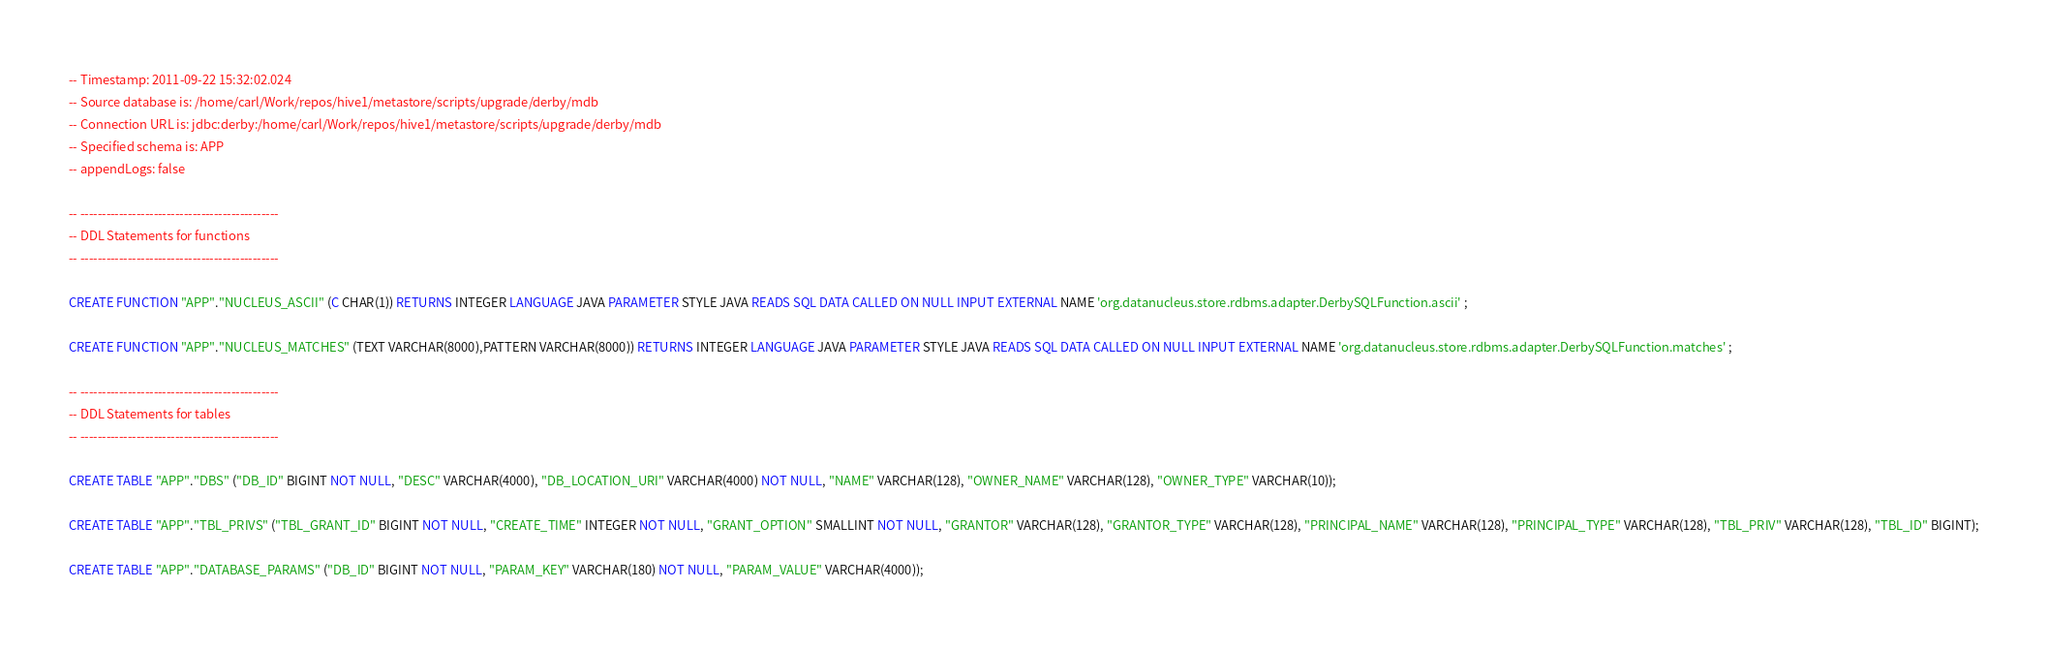<code> <loc_0><loc_0><loc_500><loc_500><_SQL_>-- Timestamp: 2011-09-22 15:32:02.024
-- Source database is: /home/carl/Work/repos/hive1/metastore/scripts/upgrade/derby/mdb
-- Connection URL is: jdbc:derby:/home/carl/Work/repos/hive1/metastore/scripts/upgrade/derby/mdb
-- Specified schema is: APP
-- appendLogs: false

-- ----------------------------------------------
-- DDL Statements for functions
-- ----------------------------------------------

CREATE FUNCTION "APP"."NUCLEUS_ASCII" (C CHAR(1)) RETURNS INTEGER LANGUAGE JAVA PARAMETER STYLE JAVA READS SQL DATA CALLED ON NULL INPUT EXTERNAL NAME 'org.datanucleus.store.rdbms.adapter.DerbySQLFunction.ascii' ;

CREATE FUNCTION "APP"."NUCLEUS_MATCHES" (TEXT VARCHAR(8000),PATTERN VARCHAR(8000)) RETURNS INTEGER LANGUAGE JAVA PARAMETER STYLE JAVA READS SQL DATA CALLED ON NULL INPUT EXTERNAL NAME 'org.datanucleus.store.rdbms.adapter.DerbySQLFunction.matches' ;

-- ----------------------------------------------
-- DDL Statements for tables
-- ----------------------------------------------

CREATE TABLE "APP"."DBS" ("DB_ID" BIGINT NOT NULL, "DESC" VARCHAR(4000), "DB_LOCATION_URI" VARCHAR(4000) NOT NULL, "NAME" VARCHAR(128), "OWNER_NAME" VARCHAR(128), "OWNER_TYPE" VARCHAR(10));

CREATE TABLE "APP"."TBL_PRIVS" ("TBL_GRANT_ID" BIGINT NOT NULL, "CREATE_TIME" INTEGER NOT NULL, "GRANT_OPTION" SMALLINT NOT NULL, "GRANTOR" VARCHAR(128), "GRANTOR_TYPE" VARCHAR(128), "PRINCIPAL_NAME" VARCHAR(128), "PRINCIPAL_TYPE" VARCHAR(128), "TBL_PRIV" VARCHAR(128), "TBL_ID" BIGINT);

CREATE TABLE "APP"."DATABASE_PARAMS" ("DB_ID" BIGINT NOT NULL, "PARAM_KEY" VARCHAR(180) NOT NULL, "PARAM_VALUE" VARCHAR(4000));
</code> 